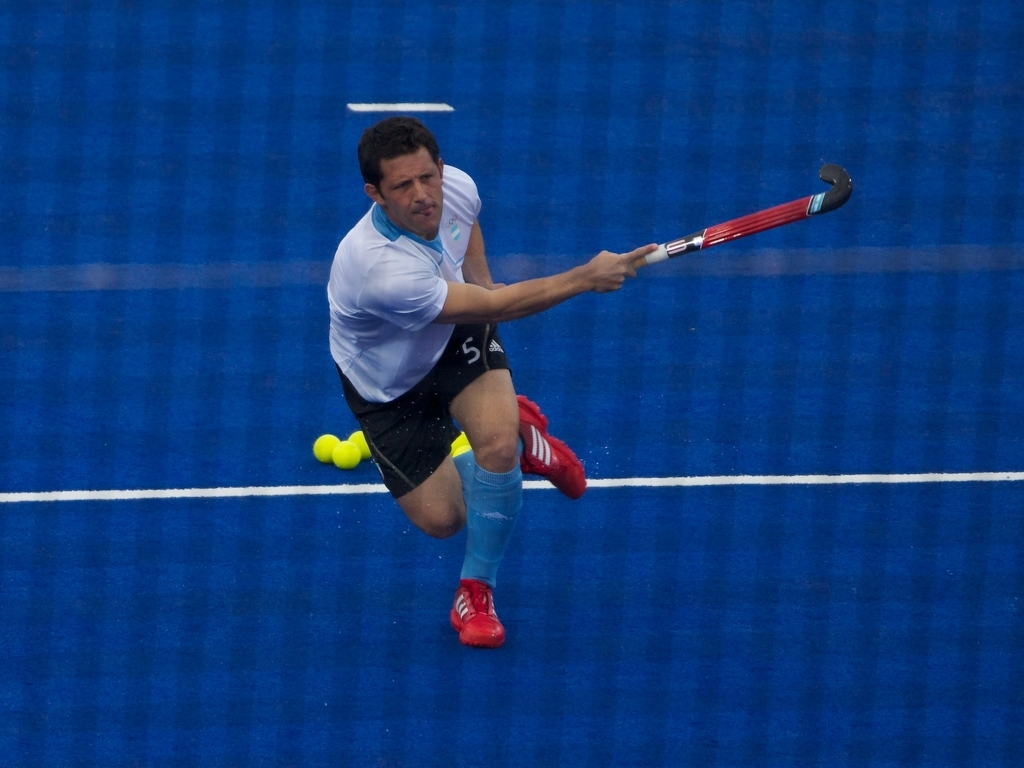What can we infer about the player's skill level and the intensity of the game? The player exhibits a high skill level; his focused expression and the precision of his body alignment during a demanding physical maneuver reflect expertise and athleticism. It implies a high-intensity match where such skillful plays are likely a common sight. What might be the significance of the player's attire and equipment in this sport? In field hockey, the attire and equipment are crucial for performance and safety. The player’s uniform allows for agility and flexibility, while protective gear like shin guards prevent injuries. The hockey stick's design contributes to the player’s ability to control and shoot the ball accurately. 